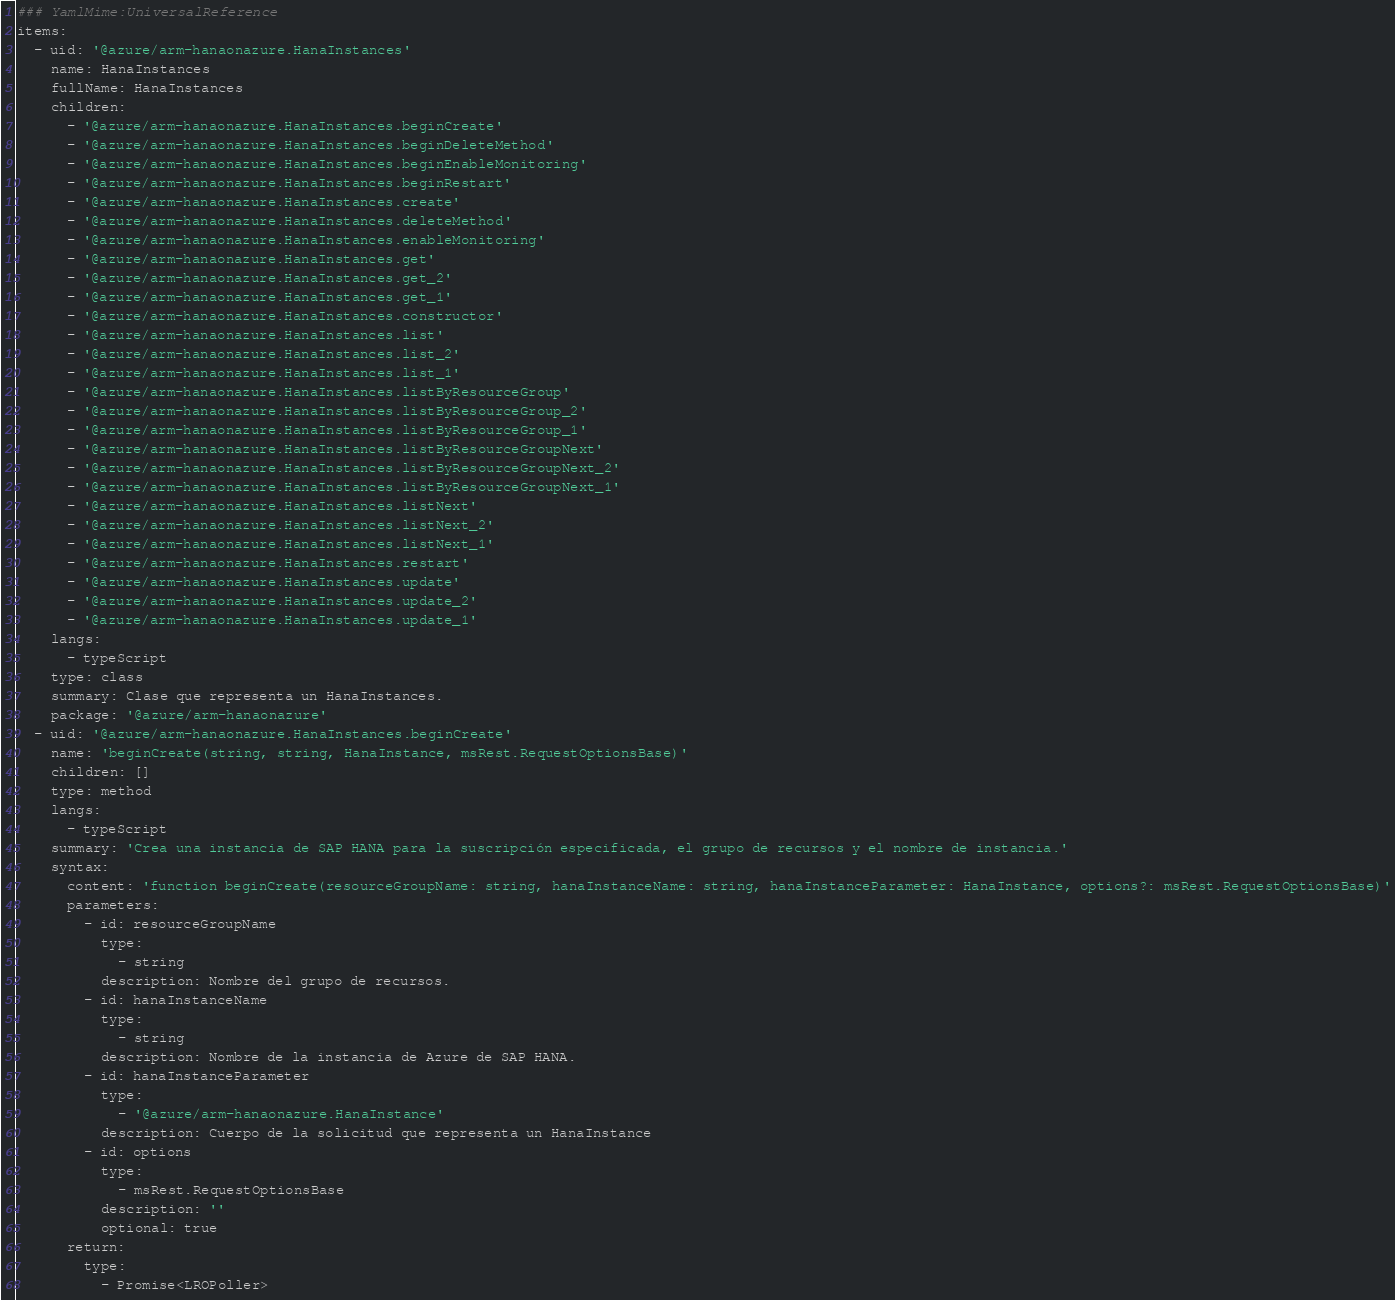<code> <loc_0><loc_0><loc_500><loc_500><_YAML_>### YamlMime:UniversalReference
items:
  - uid: '@azure/arm-hanaonazure.HanaInstances'
    name: HanaInstances
    fullName: HanaInstances
    children:
      - '@azure/arm-hanaonazure.HanaInstances.beginCreate'
      - '@azure/arm-hanaonazure.HanaInstances.beginDeleteMethod'
      - '@azure/arm-hanaonazure.HanaInstances.beginEnableMonitoring'
      - '@azure/arm-hanaonazure.HanaInstances.beginRestart'
      - '@azure/arm-hanaonazure.HanaInstances.create'
      - '@azure/arm-hanaonazure.HanaInstances.deleteMethod'
      - '@azure/arm-hanaonazure.HanaInstances.enableMonitoring'
      - '@azure/arm-hanaonazure.HanaInstances.get'
      - '@azure/arm-hanaonazure.HanaInstances.get_2'
      - '@azure/arm-hanaonazure.HanaInstances.get_1'
      - '@azure/arm-hanaonazure.HanaInstances.constructor'
      - '@azure/arm-hanaonazure.HanaInstances.list'
      - '@azure/arm-hanaonazure.HanaInstances.list_2'
      - '@azure/arm-hanaonazure.HanaInstances.list_1'
      - '@azure/arm-hanaonazure.HanaInstances.listByResourceGroup'
      - '@azure/arm-hanaonazure.HanaInstances.listByResourceGroup_2'
      - '@azure/arm-hanaonazure.HanaInstances.listByResourceGroup_1'
      - '@azure/arm-hanaonazure.HanaInstances.listByResourceGroupNext'
      - '@azure/arm-hanaonazure.HanaInstances.listByResourceGroupNext_2'
      - '@azure/arm-hanaonazure.HanaInstances.listByResourceGroupNext_1'
      - '@azure/arm-hanaonazure.HanaInstances.listNext'
      - '@azure/arm-hanaonazure.HanaInstances.listNext_2'
      - '@azure/arm-hanaonazure.HanaInstances.listNext_1'
      - '@azure/arm-hanaonazure.HanaInstances.restart'
      - '@azure/arm-hanaonazure.HanaInstances.update'
      - '@azure/arm-hanaonazure.HanaInstances.update_2'
      - '@azure/arm-hanaonazure.HanaInstances.update_1'
    langs:
      - typeScript
    type: class
    summary: Clase que representa un HanaInstances.
    package: '@azure/arm-hanaonazure'
  - uid: '@azure/arm-hanaonazure.HanaInstances.beginCreate'
    name: 'beginCreate(string, string, HanaInstance, msRest.RequestOptionsBase)'
    children: []
    type: method
    langs:
      - typeScript
    summary: 'Crea una instancia de SAP HANA para la suscripción especificada, el grupo de recursos y el nombre de instancia.'
    syntax:
      content: 'function beginCreate(resourceGroupName: string, hanaInstanceName: string, hanaInstanceParameter: HanaInstance, options?: msRest.RequestOptionsBase)'
      parameters:
        - id: resourceGroupName
          type:
            - string
          description: Nombre del grupo de recursos.
        - id: hanaInstanceName
          type:
            - string
          description: Nombre de la instancia de Azure de SAP HANA.
        - id: hanaInstanceParameter
          type:
            - '@azure/arm-hanaonazure.HanaInstance'
          description: Cuerpo de la solicitud que representa un HanaInstance
        - id: options
          type:
            - msRest.RequestOptionsBase
          description: ''
          optional: true
      return:
        type:
          - Promise<LROPoller></code> 